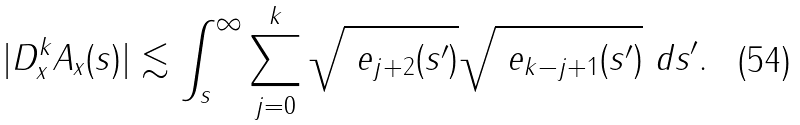Convert formula to latex. <formula><loc_0><loc_0><loc_500><loc_500>| D _ { x } ^ { k } A _ { x } ( s ) | \lesssim \int _ { s } ^ { \infty } \sum _ { j = 0 } ^ { k } \sqrt { \ e _ { j + 2 } ( s ^ { \prime } ) } \sqrt { \ e _ { k - j + 1 } ( s ^ { \prime } ) } \ d s ^ { \prime } .</formula> 